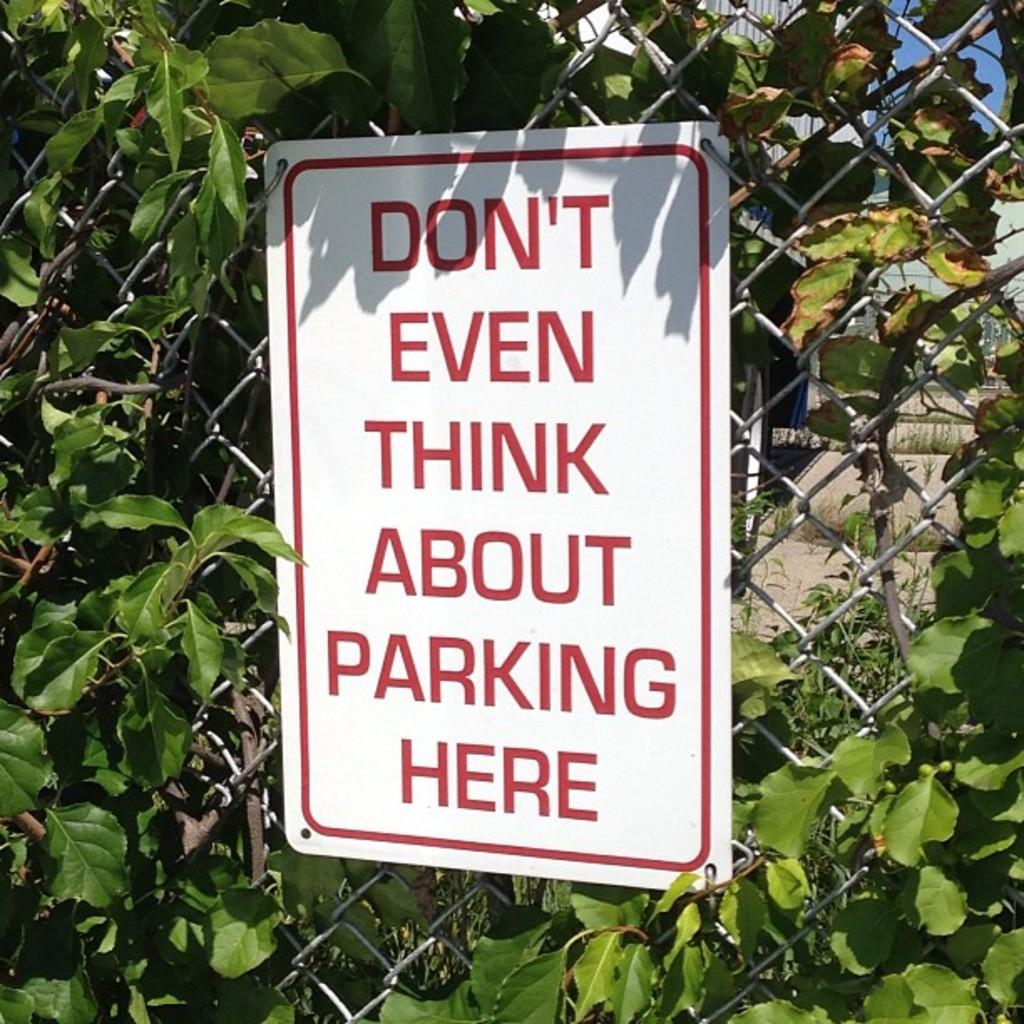What is the main object in the image? There is a white color board in the image. How is the color board positioned in the image? The board is attached to a fence. What is written on the color board? There is writing on the board. What can be seen in the surroundings of the color board? Leaves are visible around the board. How many wrists are visible in the image? There are no wrists visible in the image. What type of harmony is being displayed by the crowd in the image? There is no crowd present in the image, and therefore no harmony to be displayed. 